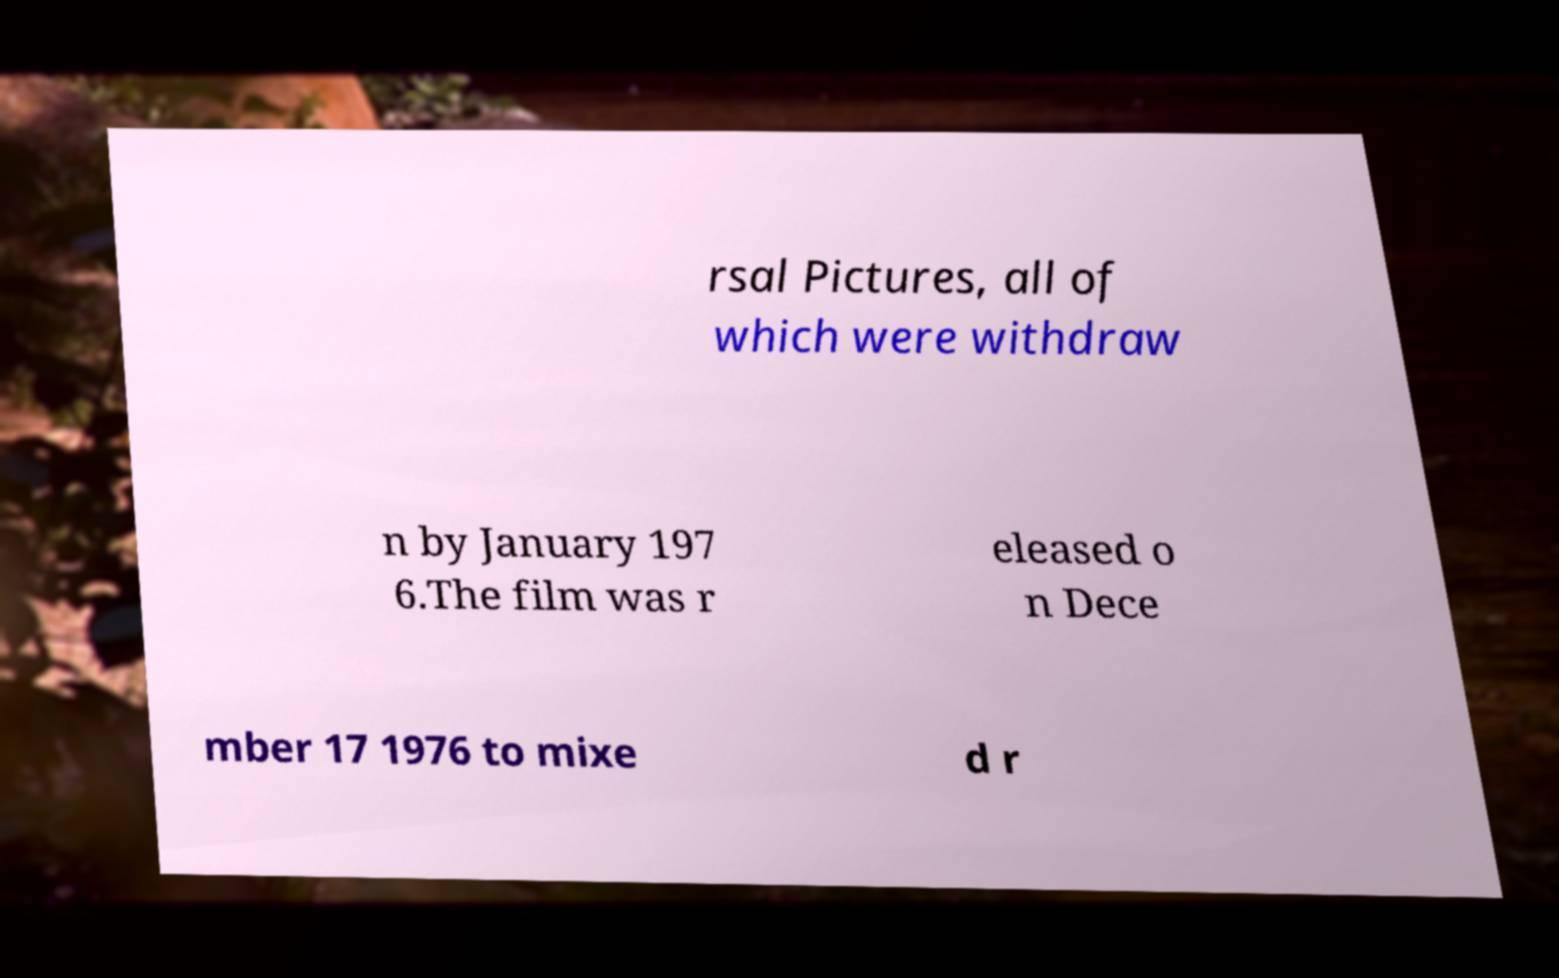Could you extract and type out the text from this image? rsal Pictures, all of which were withdraw n by January 197 6.The film was r eleased o n Dece mber 17 1976 to mixe d r 